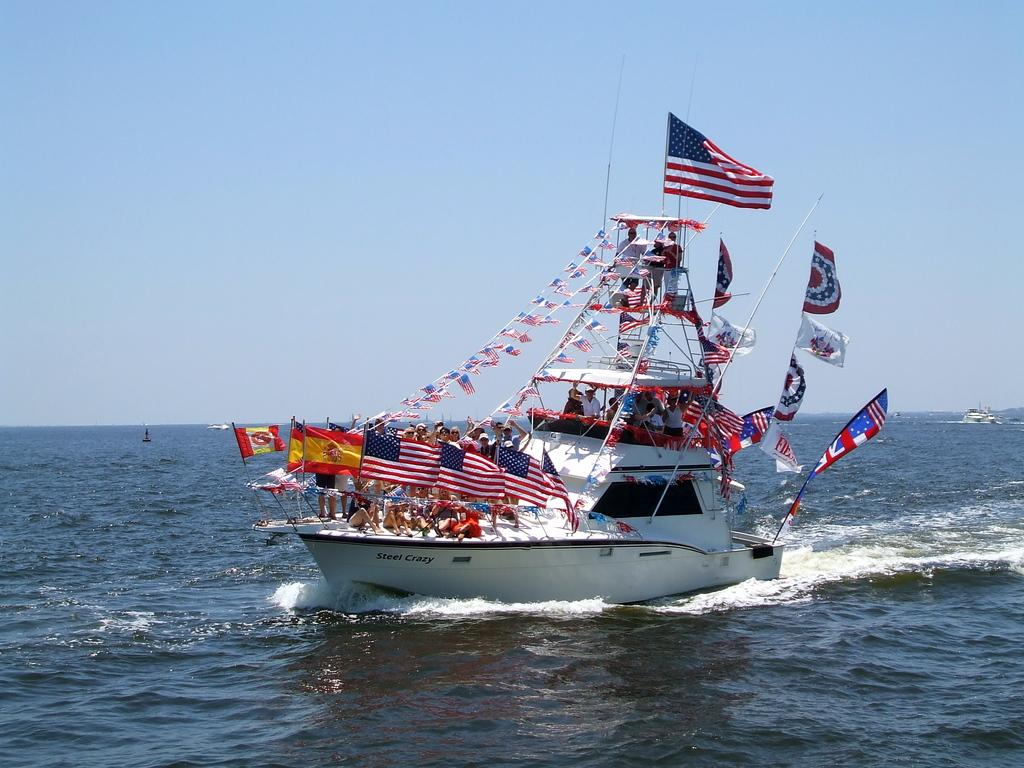<image>
Relay a brief, clear account of the picture shown. Ship with many flags on it and the words "Steel Crazy" on the bottom. 